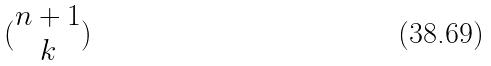<formula> <loc_0><loc_0><loc_500><loc_500>( \begin{matrix} n + 1 \\ k \end{matrix} )</formula> 